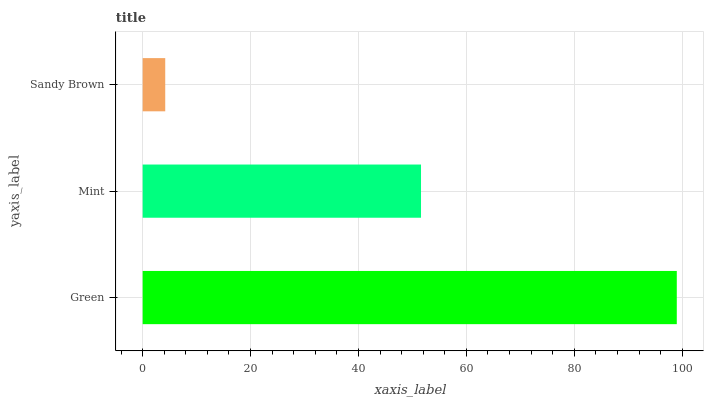Is Sandy Brown the minimum?
Answer yes or no. Yes. Is Green the maximum?
Answer yes or no. Yes. Is Mint the minimum?
Answer yes or no. No. Is Mint the maximum?
Answer yes or no. No. Is Green greater than Mint?
Answer yes or no. Yes. Is Mint less than Green?
Answer yes or no. Yes. Is Mint greater than Green?
Answer yes or no. No. Is Green less than Mint?
Answer yes or no. No. Is Mint the high median?
Answer yes or no. Yes. Is Mint the low median?
Answer yes or no. Yes. Is Sandy Brown the high median?
Answer yes or no. No. Is Green the low median?
Answer yes or no. No. 